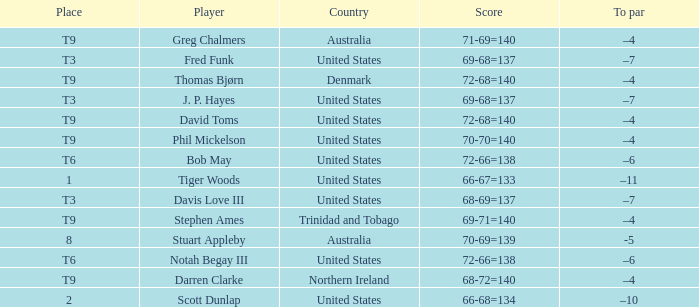What country is Stephen Ames from with a place value of t9? Trinidad and Tobago. 